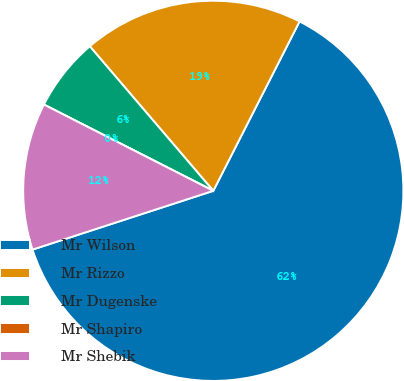Convert chart. <chart><loc_0><loc_0><loc_500><loc_500><pie_chart><fcel>Mr Wilson<fcel>Mr Rizzo<fcel>Mr Dugenske<fcel>Mr Shapiro<fcel>Mr Shebik<nl><fcel>62.5%<fcel>18.75%<fcel>6.25%<fcel>0.0%<fcel>12.5%<nl></chart> 